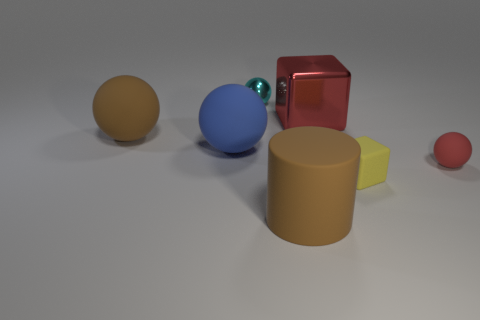Add 1 tiny red matte spheres. How many objects exist? 8 Subtract all spheres. How many objects are left? 3 Add 5 large red cubes. How many large red cubes are left? 6 Add 1 brown rubber blocks. How many brown rubber blocks exist? 1 Subtract 0 cyan cylinders. How many objects are left? 7 Subtract all blue metal cylinders. Subtract all cyan things. How many objects are left? 6 